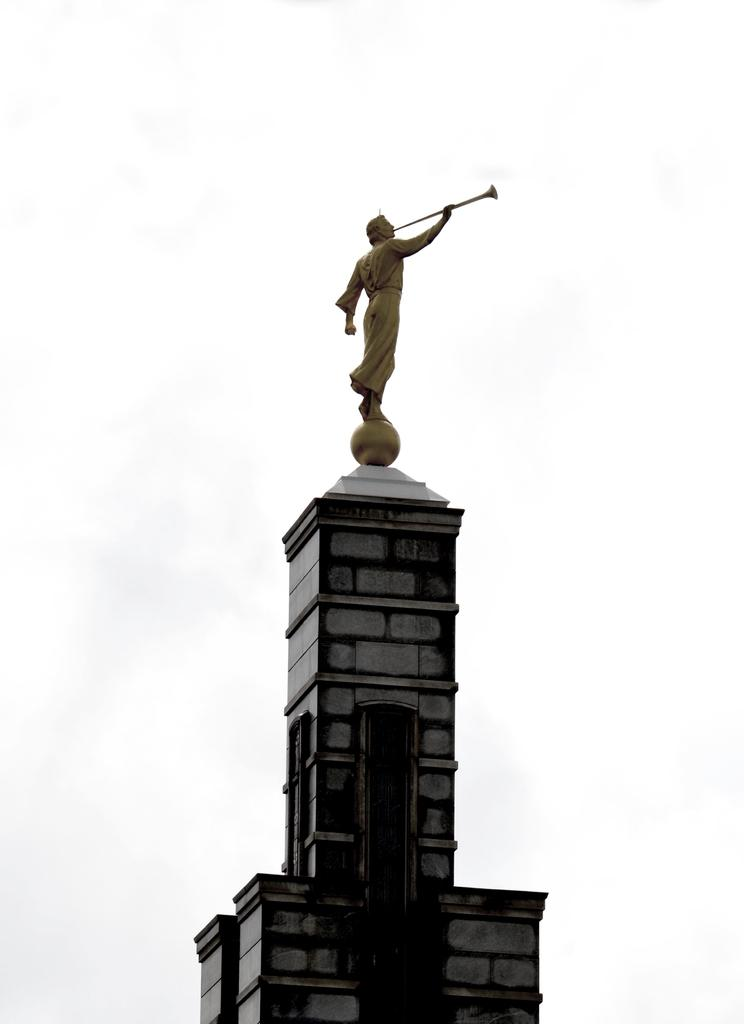What is the main subject of the image? There is a person statue in the image. Where is the statue located? The statue is on a monument building. What can be seen in the background of the image? There is sky visible in the background of the image. What is the condition of the sky in the image? There are clouds in the sky. What type of drum can be heard playing in the image? There is no drum present in the image, and therefore no sound can be heard. 